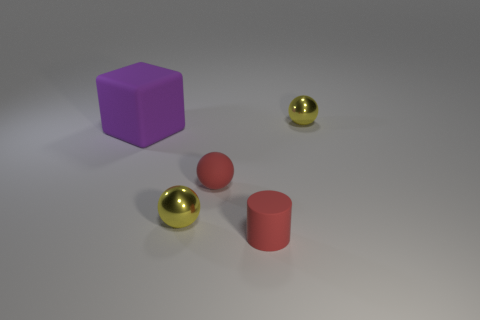Add 3 red cylinders. How many objects exist? 8 Subtract all cylinders. How many objects are left? 4 Subtract all tiny shiny objects. Subtract all tiny cylinders. How many objects are left? 2 Add 1 large purple rubber blocks. How many large purple rubber blocks are left? 2 Add 5 blue cylinders. How many blue cylinders exist? 5 Subtract 1 purple cubes. How many objects are left? 4 